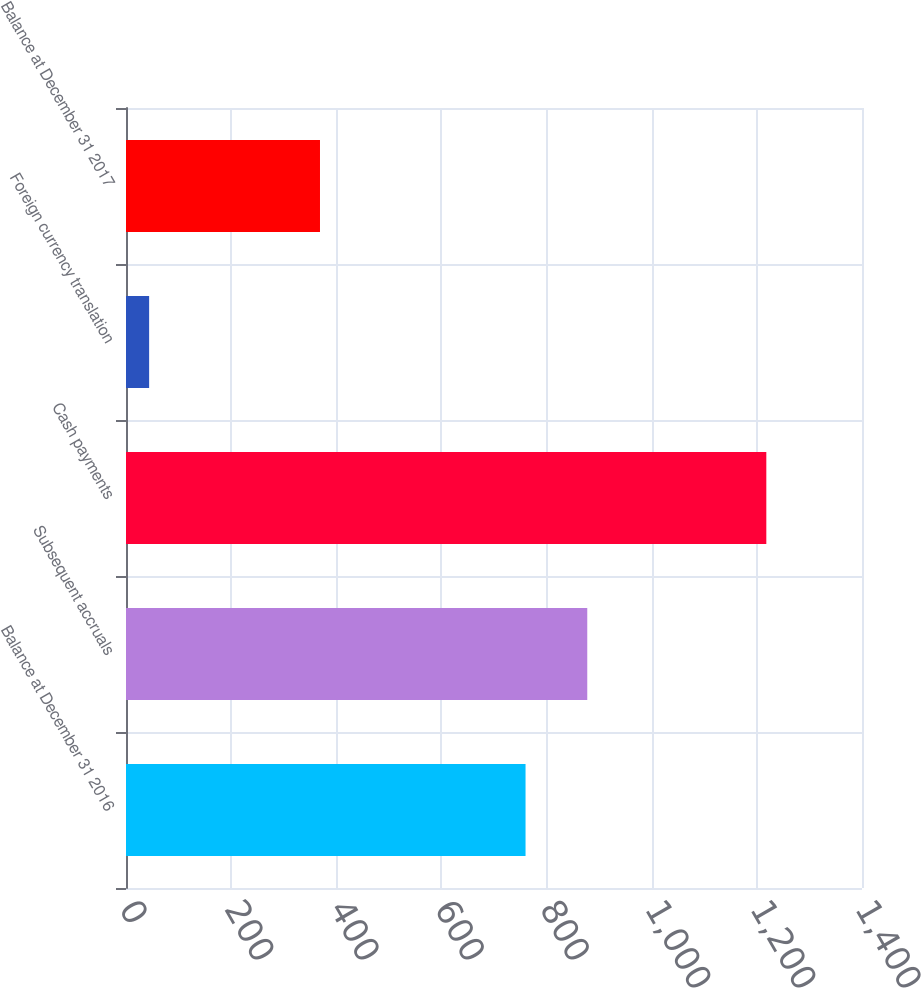Convert chart. <chart><loc_0><loc_0><loc_500><loc_500><bar_chart><fcel>Balance at December 31 2016<fcel>Subsequent accruals<fcel>Cash payments<fcel>Foreign currency translation<fcel>Balance at December 31 2017<nl><fcel>760<fcel>877.4<fcel>1218<fcel>44<fcel>369<nl></chart> 